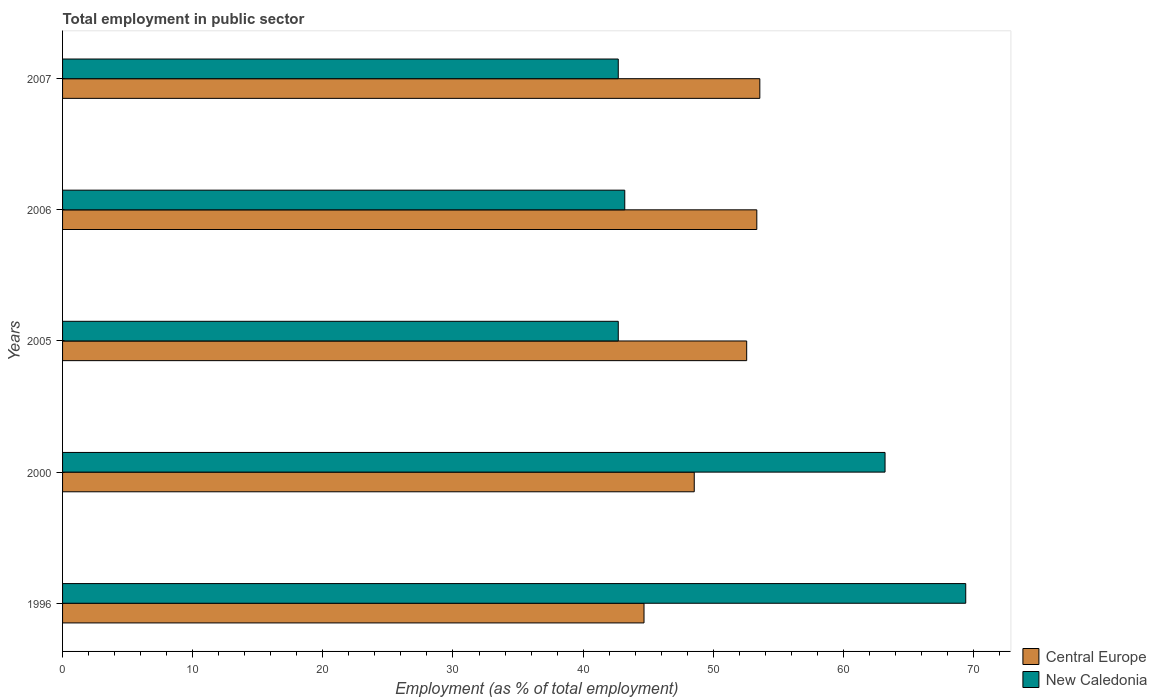How many bars are there on the 3rd tick from the bottom?
Give a very brief answer. 2. In how many cases, is the number of bars for a given year not equal to the number of legend labels?
Offer a terse response. 0. What is the employment in public sector in New Caledonia in 1996?
Ensure brevity in your answer.  69.4. Across all years, what is the maximum employment in public sector in Central Europe?
Provide a succinct answer. 53.58. Across all years, what is the minimum employment in public sector in Central Europe?
Ensure brevity in your answer.  44.68. In which year was the employment in public sector in New Caledonia maximum?
Provide a short and direct response. 1996. In which year was the employment in public sector in Central Europe minimum?
Your answer should be compact. 1996. What is the total employment in public sector in New Caledonia in the graph?
Your answer should be very brief. 261.2. What is the difference between the employment in public sector in New Caledonia in 1996 and that in 2005?
Keep it short and to the point. 26.7. What is the difference between the employment in public sector in Central Europe in 1996 and the employment in public sector in New Caledonia in 2000?
Your answer should be compact. -18.52. What is the average employment in public sector in Central Europe per year?
Offer a very short reply. 50.54. In the year 1996, what is the difference between the employment in public sector in New Caledonia and employment in public sector in Central Europe?
Make the answer very short. 24.72. In how many years, is the employment in public sector in Central Europe greater than 44 %?
Your response must be concise. 5. What is the ratio of the employment in public sector in New Caledonia in 1996 to that in 2000?
Your answer should be very brief. 1.1. Is the employment in public sector in Central Europe in 1996 less than that in 2005?
Your answer should be compact. Yes. Is the difference between the employment in public sector in New Caledonia in 2000 and 2006 greater than the difference between the employment in public sector in Central Europe in 2000 and 2006?
Give a very brief answer. Yes. What is the difference between the highest and the second highest employment in public sector in Central Europe?
Offer a very short reply. 0.23. What is the difference between the highest and the lowest employment in public sector in New Caledonia?
Your response must be concise. 26.7. What does the 1st bar from the top in 2000 represents?
Make the answer very short. New Caledonia. What does the 1st bar from the bottom in 1996 represents?
Your response must be concise. Central Europe. What is the difference between two consecutive major ticks on the X-axis?
Keep it short and to the point. 10. Does the graph contain any zero values?
Provide a succinct answer. No. Does the graph contain grids?
Ensure brevity in your answer.  No. Where does the legend appear in the graph?
Make the answer very short. Bottom right. How many legend labels are there?
Your answer should be very brief. 2. How are the legend labels stacked?
Provide a short and direct response. Vertical. What is the title of the graph?
Ensure brevity in your answer.  Total employment in public sector. Does "Guinea" appear as one of the legend labels in the graph?
Make the answer very short. No. What is the label or title of the X-axis?
Make the answer very short. Employment (as % of total employment). What is the Employment (as % of total employment) in Central Europe in 1996?
Your answer should be very brief. 44.68. What is the Employment (as % of total employment) of New Caledonia in 1996?
Offer a terse response. 69.4. What is the Employment (as % of total employment) of Central Europe in 2000?
Make the answer very short. 48.54. What is the Employment (as % of total employment) in New Caledonia in 2000?
Give a very brief answer. 63.2. What is the Employment (as % of total employment) of Central Europe in 2005?
Offer a terse response. 52.57. What is the Employment (as % of total employment) of New Caledonia in 2005?
Provide a short and direct response. 42.7. What is the Employment (as % of total employment) of Central Europe in 2006?
Your answer should be very brief. 53.35. What is the Employment (as % of total employment) in New Caledonia in 2006?
Your answer should be very brief. 43.2. What is the Employment (as % of total employment) in Central Europe in 2007?
Ensure brevity in your answer.  53.58. What is the Employment (as % of total employment) of New Caledonia in 2007?
Offer a very short reply. 42.7. Across all years, what is the maximum Employment (as % of total employment) of Central Europe?
Provide a succinct answer. 53.58. Across all years, what is the maximum Employment (as % of total employment) in New Caledonia?
Give a very brief answer. 69.4. Across all years, what is the minimum Employment (as % of total employment) of Central Europe?
Your answer should be compact. 44.68. Across all years, what is the minimum Employment (as % of total employment) of New Caledonia?
Provide a succinct answer. 42.7. What is the total Employment (as % of total employment) of Central Europe in the graph?
Ensure brevity in your answer.  252.71. What is the total Employment (as % of total employment) in New Caledonia in the graph?
Offer a terse response. 261.2. What is the difference between the Employment (as % of total employment) in Central Europe in 1996 and that in 2000?
Offer a terse response. -3.86. What is the difference between the Employment (as % of total employment) of Central Europe in 1996 and that in 2005?
Keep it short and to the point. -7.89. What is the difference between the Employment (as % of total employment) of New Caledonia in 1996 and that in 2005?
Give a very brief answer. 26.7. What is the difference between the Employment (as % of total employment) of Central Europe in 1996 and that in 2006?
Provide a succinct answer. -8.67. What is the difference between the Employment (as % of total employment) in New Caledonia in 1996 and that in 2006?
Your response must be concise. 26.2. What is the difference between the Employment (as % of total employment) in Central Europe in 1996 and that in 2007?
Ensure brevity in your answer.  -8.9. What is the difference between the Employment (as % of total employment) in New Caledonia in 1996 and that in 2007?
Give a very brief answer. 26.7. What is the difference between the Employment (as % of total employment) in Central Europe in 2000 and that in 2005?
Keep it short and to the point. -4.03. What is the difference between the Employment (as % of total employment) in New Caledonia in 2000 and that in 2005?
Provide a short and direct response. 20.5. What is the difference between the Employment (as % of total employment) of Central Europe in 2000 and that in 2006?
Offer a terse response. -4.81. What is the difference between the Employment (as % of total employment) in New Caledonia in 2000 and that in 2006?
Give a very brief answer. 20. What is the difference between the Employment (as % of total employment) of Central Europe in 2000 and that in 2007?
Provide a succinct answer. -5.04. What is the difference between the Employment (as % of total employment) of Central Europe in 2005 and that in 2006?
Keep it short and to the point. -0.78. What is the difference between the Employment (as % of total employment) in Central Europe in 2005 and that in 2007?
Give a very brief answer. -1.01. What is the difference between the Employment (as % of total employment) in Central Europe in 2006 and that in 2007?
Provide a short and direct response. -0.23. What is the difference between the Employment (as % of total employment) of New Caledonia in 2006 and that in 2007?
Provide a succinct answer. 0.5. What is the difference between the Employment (as % of total employment) in Central Europe in 1996 and the Employment (as % of total employment) in New Caledonia in 2000?
Make the answer very short. -18.52. What is the difference between the Employment (as % of total employment) in Central Europe in 1996 and the Employment (as % of total employment) in New Caledonia in 2005?
Ensure brevity in your answer.  1.98. What is the difference between the Employment (as % of total employment) in Central Europe in 1996 and the Employment (as % of total employment) in New Caledonia in 2006?
Ensure brevity in your answer.  1.48. What is the difference between the Employment (as % of total employment) in Central Europe in 1996 and the Employment (as % of total employment) in New Caledonia in 2007?
Offer a very short reply. 1.98. What is the difference between the Employment (as % of total employment) in Central Europe in 2000 and the Employment (as % of total employment) in New Caledonia in 2005?
Your answer should be very brief. 5.84. What is the difference between the Employment (as % of total employment) in Central Europe in 2000 and the Employment (as % of total employment) in New Caledonia in 2006?
Make the answer very short. 5.34. What is the difference between the Employment (as % of total employment) of Central Europe in 2000 and the Employment (as % of total employment) of New Caledonia in 2007?
Provide a short and direct response. 5.84. What is the difference between the Employment (as % of total employment) in Central Europe in 2005 and the Employment (as % of total employment) in New Caledonia in 2006?
Your answer should be very brief. 9.37. What is the difference between the Employment (as % of total employment) of Central Europe in 2005 and the Employment (as % of total employment) of New Caledonia in 2007?
Keep it short and to the point. 9.87. What is the difference between the Employment (as % of total employment) of Central Europe in 2006 and the Employment (as % of total employment) of New Caledonia in 2007?
Your response must be concise. 10.65. What is the average Employment (as % of total employment) in Central Europe per year?
Provide a succinct answer. 50.54. What is the average Employment (as % of total employment) in New Caledonia per year?
Keep it short and to the point. 52.24. In the year 1996, what is the difference between the Employment (as % of total employment) in Central Europe and Employment (as % of total employment) in New Caledonia?
Make the answer very short. -24.72. In the year 2000, what is the difference between the Employment (as % of total employment) of Central Europe and Employment (as % of total employment) of New Caledonia?
Your response must be concise. -14.66. In the year 2005, what is the difference between the Employment (as % of total employment) in Central Europe and Employment (as % of total employment) in New Caledonia?
Provide a succinct answer. 9.87. In the year 2006, what is the difference between the Employment (as % of total employment) in Central Europe and Employment (as % of total employment) in New Caledonia?
Offer a very short reply. 10.15. In the year 2007, what is the difference between the Employment (as % of total employment) in Central Europe and Employment (as % of total employment) in New Caledonia?
Provide a succinct answer. 10.88. What is the ratio of the Employment (as % of total employment) in Central Europe in 1996 to that in 2000?
Ensure brevity in your answer.  0.92. What is the ratio of the Employment (as % of total employment) of New Caledonia in 1996 to that in 2000?
Offer a very short reply. 1.1. What is the ratio of the Employment (as % of total employment) of Central Europe in 1996 to that in 2005?
Offer a very short reply. 0.85. What is the ratio of the Employment (as % of total employment) of New Caledonia in 1996 to that in 2005?
Provide a succinct answer. 1.63. What is the ratio of the Employment (as % of total employment) in Central Europe in 1996 to that in 2006?
Provide a succinct answer. 0.84. What is the ratio of the Employment (as % of total employment) in New Caledonia in 1996 to that in 2006?
Offer a very short reply. 1.61. What is the ratio of the Employment (as % of total employment) in Central Europe in 1996 to that in 2007?
Make the answer very short. 0.83. What is the ratio of the Employment (as % of total employment) of New Caledonia in 1996 to that in 2007?
Offer a very short reply. 1.63. What is the ratio of the Employment (as % of total employment) of Central Europe in 2000 to that in 2005?
Your response must be concise. 0.92. What is the ratio of the Employment (as % of total employment) in New Caledonia in 2000 to that in 2005?
Offer a terse response. 1.48. What is the ratio of the Employment (as % of total employment) in Central Europe in 2000 to that in 2006?
Give a very brief answer. 0.91. What is the ratio of the Employment (as % of total employment) in New Caledonia in 2000 to that in 2006?
Ensure brevity in your answer.  1.46. What is the ratio of the Employment (as % of total employment) of Central Europe in 2000 to that in 2007?
Offer a terse response. 0.91. What is the ratio of the Employment (as % of total employment) of New Caledonia in 2000 to that in 2007?
Provide a succinct answer. 1.48. What is the ratio of the Employment (as % of total employment) of Central Europe in 2005 to that in 2006?
Offer a terse response. 0.99. What is the ratio of the Employment (as % of total employment) of New Caledonia in 2005 to that in 2006?
Offer a terse response. 0.99. What is the ratio of the Employment (as % of total employment) in Central Europe in 2005 to that in 2007?
Provide a short and direct response. 0.98. What is the ratio of the Employment (as % of total employment) of New Caledonia in 2005 to that in 2007?
Your answer should be very brief. 1. What is the ratio of the Employment (as % of total employment) in New Caledonia in 2006 to that in 2007?
Provide a short and direct response. 1.01. What is the difference between the highest and the second highest Employment (as % of total employment) in Central Europe?
Keep it short and to the point. 0.23. What is the difference between the highest and the lowest Employment (as % of total employment) in Central Europe?
Your response must be concise. 8.9. What is the difference between the highest and the lowest Employment (as % of total employment) of New Caledonia?
Your answer should be very brief. 26.7. 